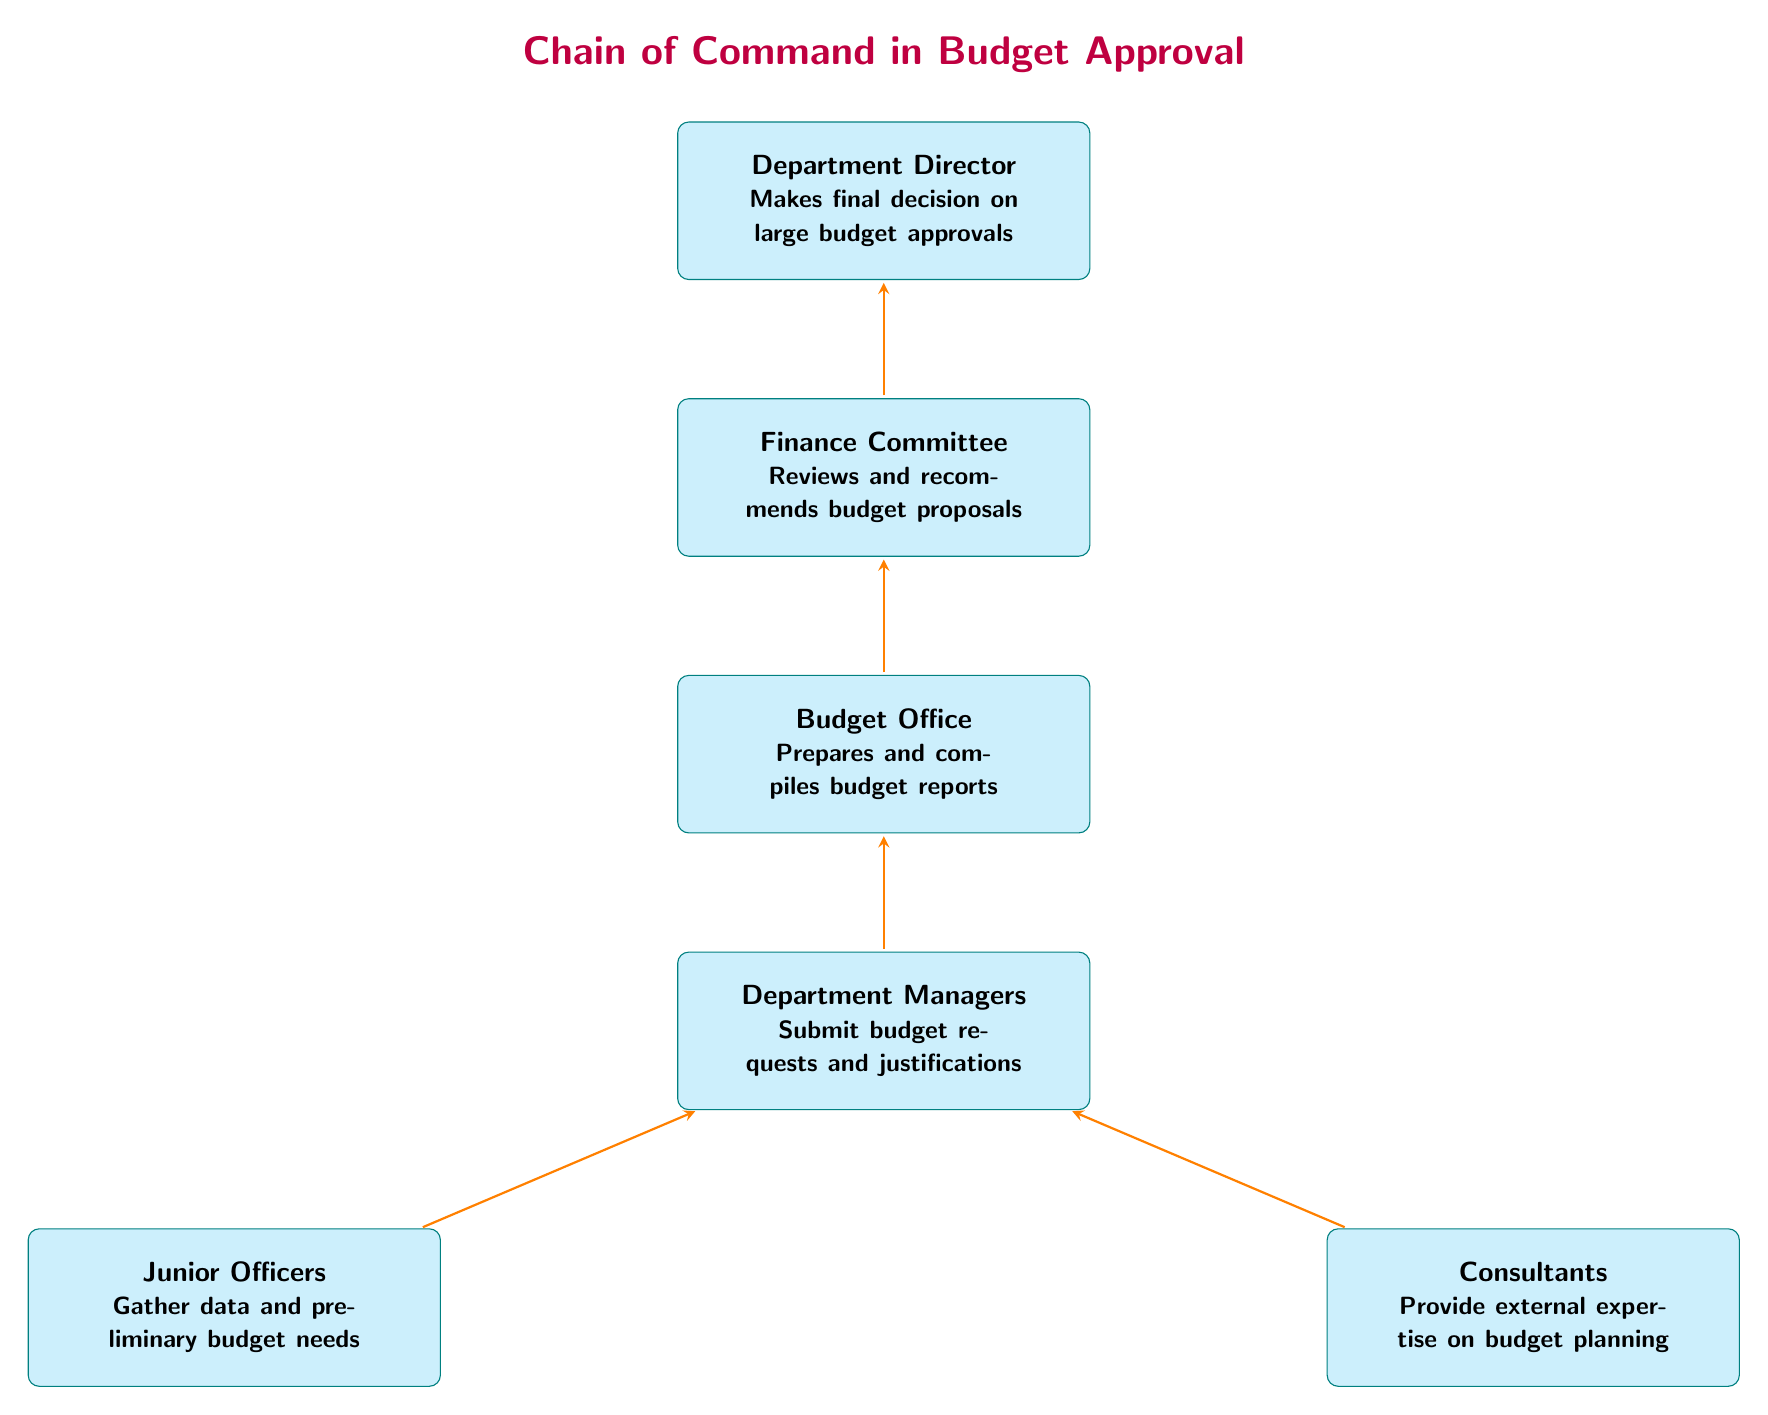What is the top node in the diagram? The top node in the diagram represents the Department Director, who is the highest authority in the budget approval process. This can be identified as the first node at the top of the diagram.
Answer: Department Director How many nodes are in the diagram? The diagram contains a total of five nodes, each representing a different role in the budget approval process. By counting each distinct box in the diagram, we arrive at this total.
Answer: Five What role reviews and recommends budget proposals? The Finance Committee is the role responsible for reviewing and recommending budget proposals, as indicated by the specific text within its box in the diagram.
Answer: Finance Committee Who submits budget requests and justifications? Department Managers are responsible for submitting budget requests and justifications, as stated in the box corresponding to that role.
Answer: Department Managers Which role is at the bottom of the chain? The Junior Officers and Consultants are positioned at the bottom of the chain, representing the foundational roles that gather data and provide expertise, respectively. However, Junior Officers is the leftmost node if asked for the specific bottom node.
Answer: Junior Officers What is the relationship between Department Managers and the Budget Office? Department Managers submit budget requests and justifications to the Budget Office, which compiles these into budget reports. This relationship indicates a direct flow of information from one box to another in the diagram.
Answer: Submit Which role has the final decision-making authority on budget approvals? The Department Director has the final decision-making authority on large budget approvals as depicted in the diagram, which clearly outlines this authority.
Answer: Department Director How does the Budget Office interact with the Finance Committee? The Budget Office prepares and compiles budget reports, which are then reviewed by the Finance Committee. This points to a directional flow of information from the Budget Office to the Finance Committee in the diagram.
Answer: Reviews What type of expertise do Consultants provide? Consultants provide external expertise on budget planning, as described in the corresponding box within the diagram, highlighting their role in the budget process.
Answer: External expertise 